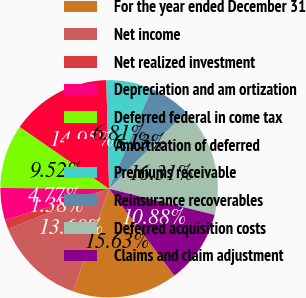Convert chart. <chart><loc_0><loc_0><loc_500><loc_500><pie_chart><fcel>For the year ended December 31<fcel>Net income<fcel>Net realized investment<fcel>Depreciation and am ortization<fcel>Deferred federal in come tax<fcel>Amortization of deferred<fcel>Premiums receivable<fcel>Reinsurance recoverables<fcel>Deferred acquisition costs<fcel>Claims and claim adjustment<nl><fcel>15.63%<fcel>13.6%<fcel>1.38%<fcel>4.77%<fcel>9.52%<fcel>14.95%<fcel>6.81%<fcel>6.13%<fcel>16.31%<fcel>10.88%<nl></chart> 